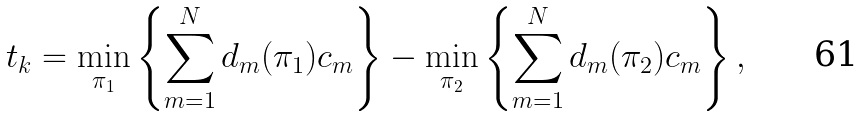<formula> <loc_0><loc_0><loc_500><loc_500>t _ { k } = \min _ { \pi _ { 1 } } \left \{ \sum _ { m = 1 } ^ { N } d _ { m } ( \pi _ { 1 } ) c _ { m } \right \} - \min _ { \pi _ { 2 } } \left \{ \sum _ { m = 1 } ^ { N } d _ { m } ( \pi _ { 2 } ) c _ { m } \right \} ,</formula> 